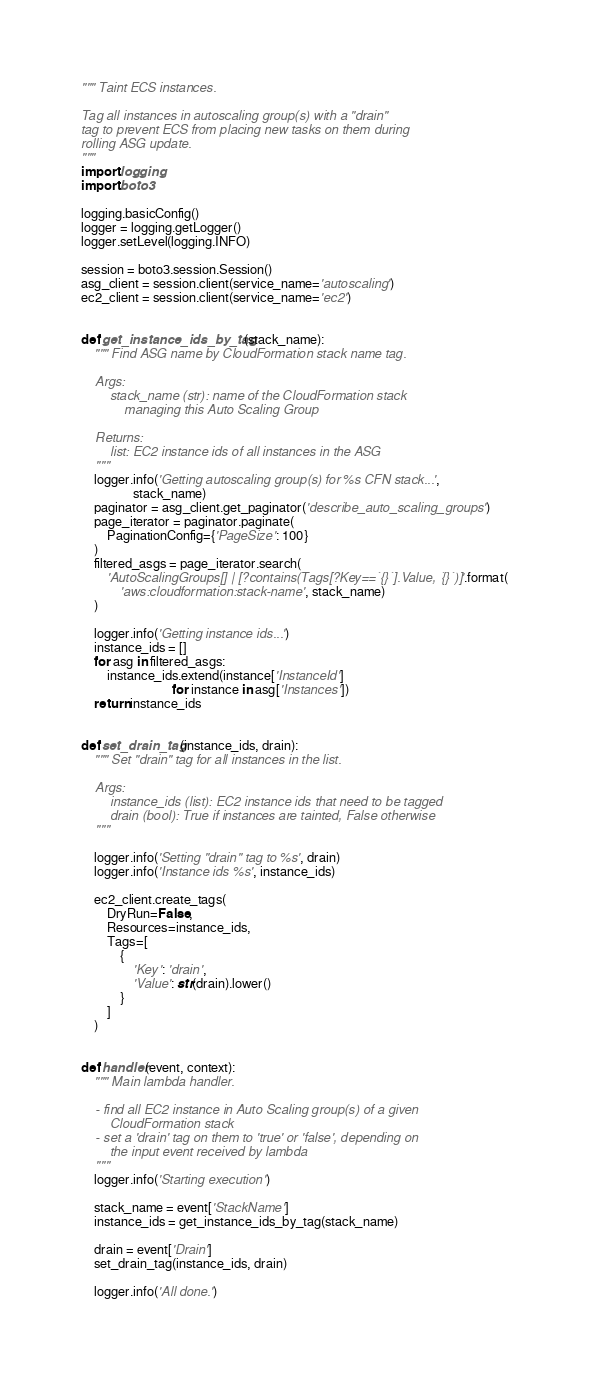Convert code to text. <code><loc_0><loc_0><loc_500><loc_500><_Python_>""" Taint ECS instances.

Tag all instances in autoscaling group(s) with a "drain"
tag to prevent ECS from placing new tasks on them during
rolling ASG update.
"""
import logging
import boto3

logging.basicConfig()
logger = logging.getLogger()
logger.setLevel(logging.INFO)

session = boto3.session.Session()
asg_client = session.client(service_name='autoscaling')
ec2_client = session.client(service_name='ec2')


def get_instance_ids_by_tag(stack_name):
    """ Find ASG name by CloudFormation stack name tag.

    Args:
        stack_name (str): name of the CloudFormation stack
            managing this Auto Scaling Group

    Returns:
        list: EC2 instance ids of all instances in the ASG
    """
    logger.info('Getting autoscaling group(s) for %s CFN stack...',
                stack_name)
    paginator = asg_client.get_paginator('describe_auto_scaling_groups')
    page_iterator = paginator.paginate(
        PaginationConfig={'PageSize': 100}
    )
    filtered_asgs = page_iterator.search(
        'AutoScalingGroups[] | [?contains(Tags[?Key==`{}`].Value, `{}`)]'.format(
            'aws:cloudformation:stack-name', stack_name)
    )

    logger.info('Getting instance ids...')
    instance_ids = []
    for asg in filtered_asgs:
        instance_ids.extend(instance['InstanceId']
                            for instance in asg['Instances'])
    return instance_ids


def set_drain_tag(instance_ids, drain):
    """ Set "drain" tag for all instances in the list.

    Args:
        instance_ids (list): EC2 instance ids that need to be tagged
        drain (bool): True if instances are tainted, False otherwise
    """

    logger.info('Setting "drain" tag to %s', drain)
    logger.info('Instance ids %s', instance_ids)

    ec2_client.create_tags(
        DryRun=False,
        Resources=instance_ids,
        Tags=[
            {
                'Key': 'drain',
                'Value': str(drain).lower()
            }
        ]
    )


def handler(event, context):
    """ Main lambda handler.

    - find all EC2 instance in Auto Scaling group(s) of a given
        CloudFormation stack
    - set a 'drain' tag on them to 'true' or 'false', depending on
        the input event received by lambda
    """
    logger.info('Starting execution')

    stack_name = event['StackName']
    instance_ids = get_instance_ids_by_tag(stack_name)

    drain = event['Drain']
    set_drain_tag(instance_ids, drain)

    logger.info('All done.')
</code> 